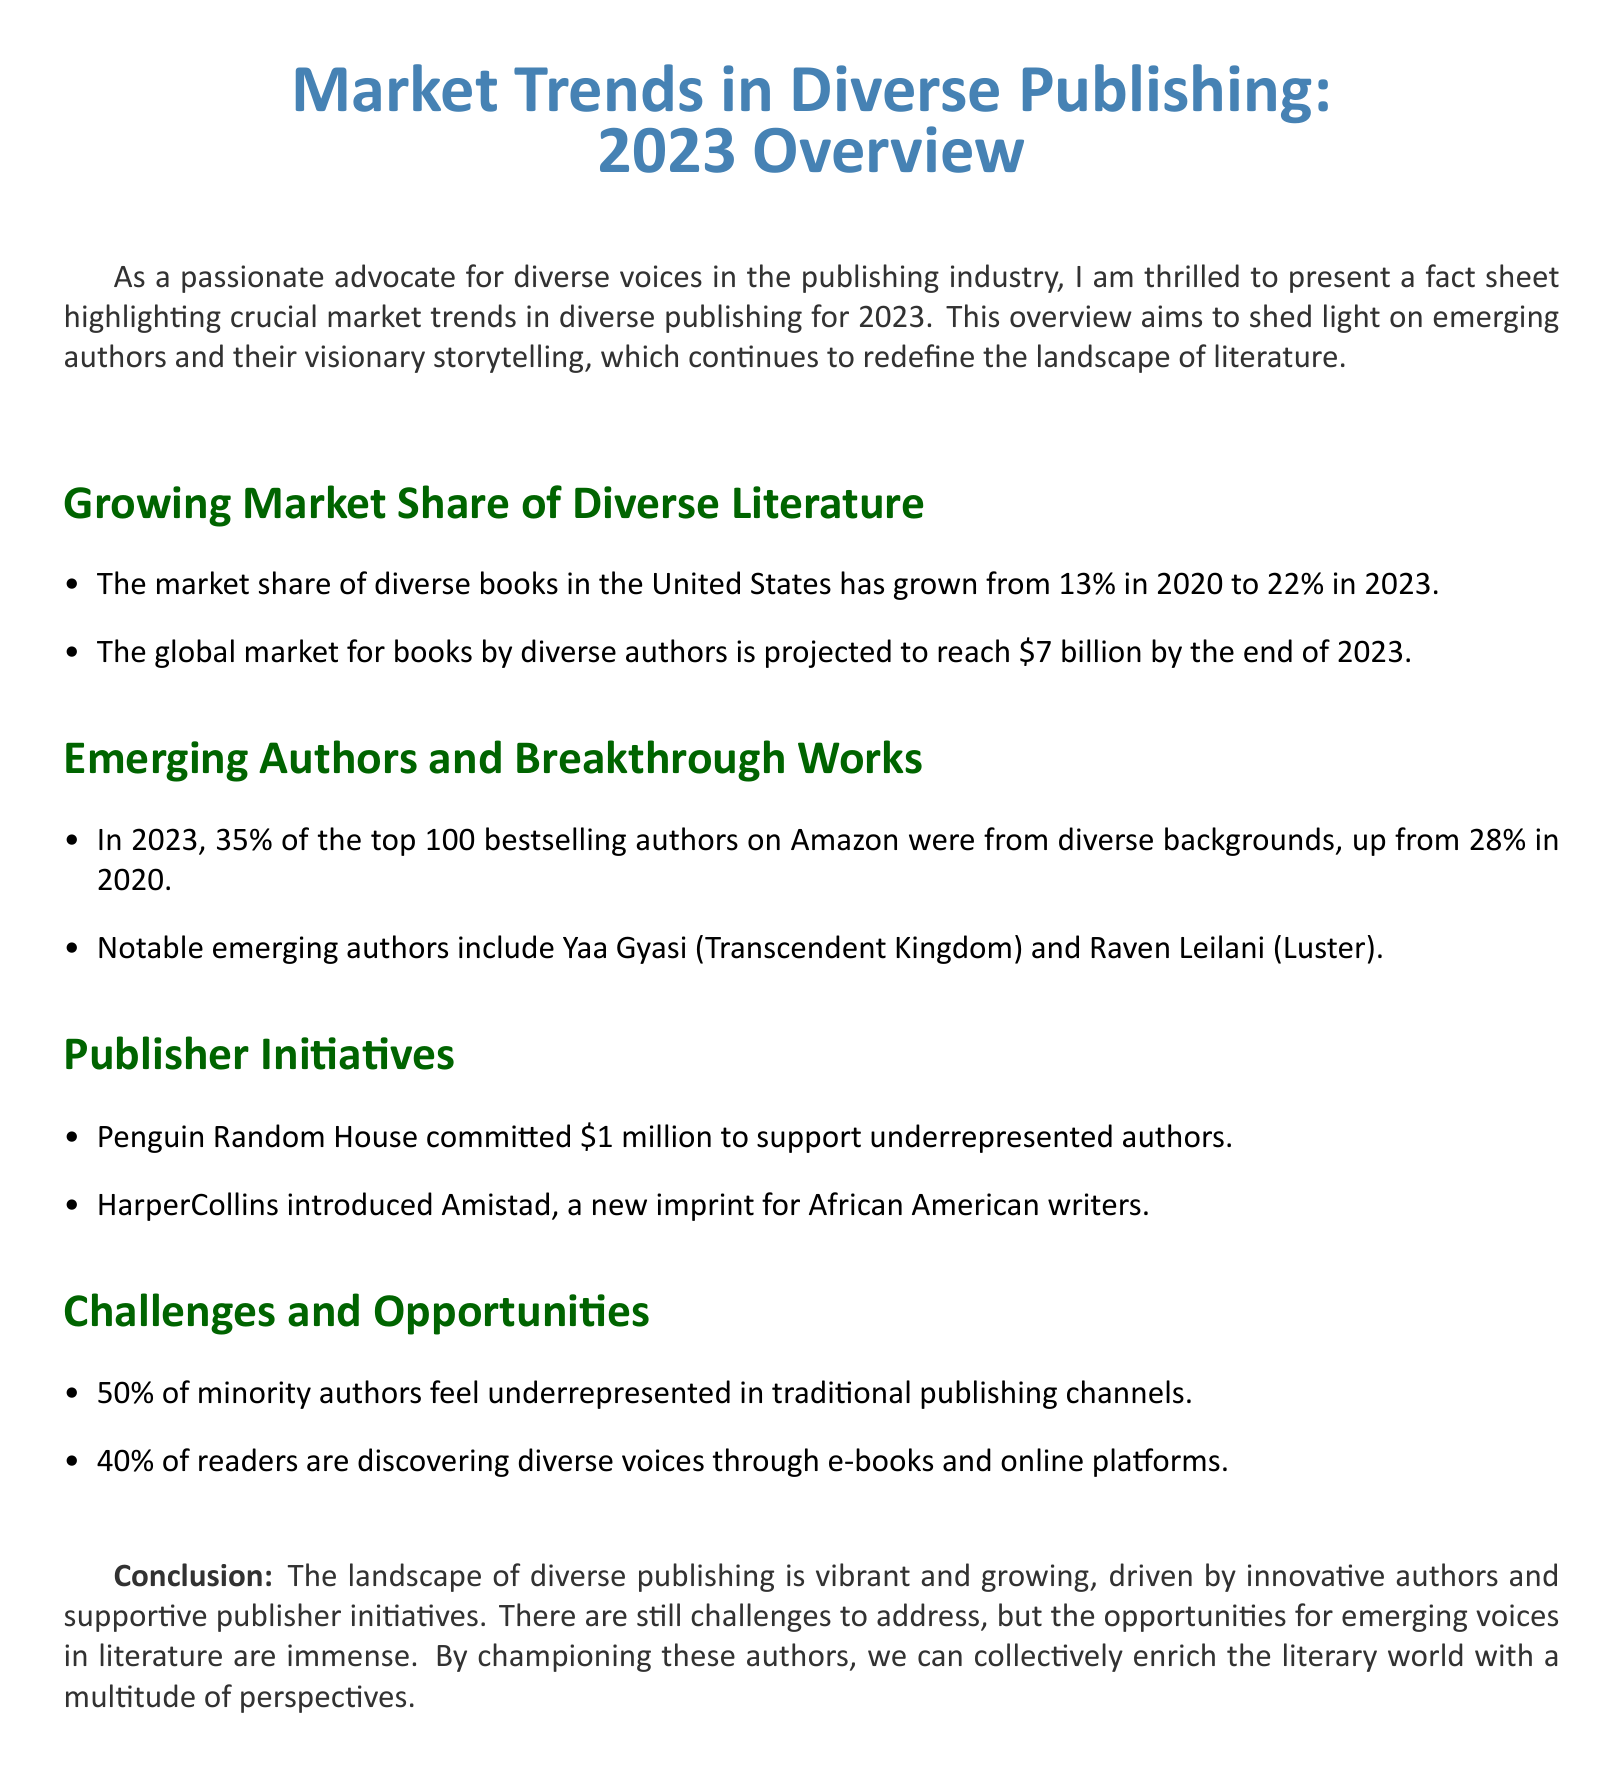What was the market share of diverse books in 2020? The document states that the market share of diverse books in the United States was 13% in 2020.
Answer: 13% What is the projected global market for books by diverse authors in 2023? According to the document, the global market for books by diverse authors is projected to reach $7 billion by the end of 2023.
Answer: $7 billion What percentage of the top 100 bestselling authors on Amazon were from diverse backgrounds in 2023? The document mentions that 35% of the top 100 bestselling authors on Amazon were from diverse backgrounds in 2023.
Answer: 35% Which new imprint did HarperCollins introduce for African American writers? The document states that HarperCollins introduced Amistad as a new imprint for African American writers.
Answer: Amistad What percentage of minority authors feel underrepresented in traditional publishing channels? According to the document, 50% of minority authors feel underrepresented in traditional publishing channels.
Answer: 50% What is one notable emerging author mentioned in the document? The document lists Yaa Gyasi and Raven Leilani as notable emerging authors.
Answer: Yaa Gyasi What is the increase in the percentage of diverse authors among the top 100 bestselling authors from 2020 to 2023? The document highlights an increase from 28% in 2020 to 35% in 2023, which is a 7% increase.
Answer: 7% What percentage of readers discover diverse voices through e-books and online platforms? The document states that 40% of readers discover diverse voices through e-books and online platforms.
Answer: 40% 